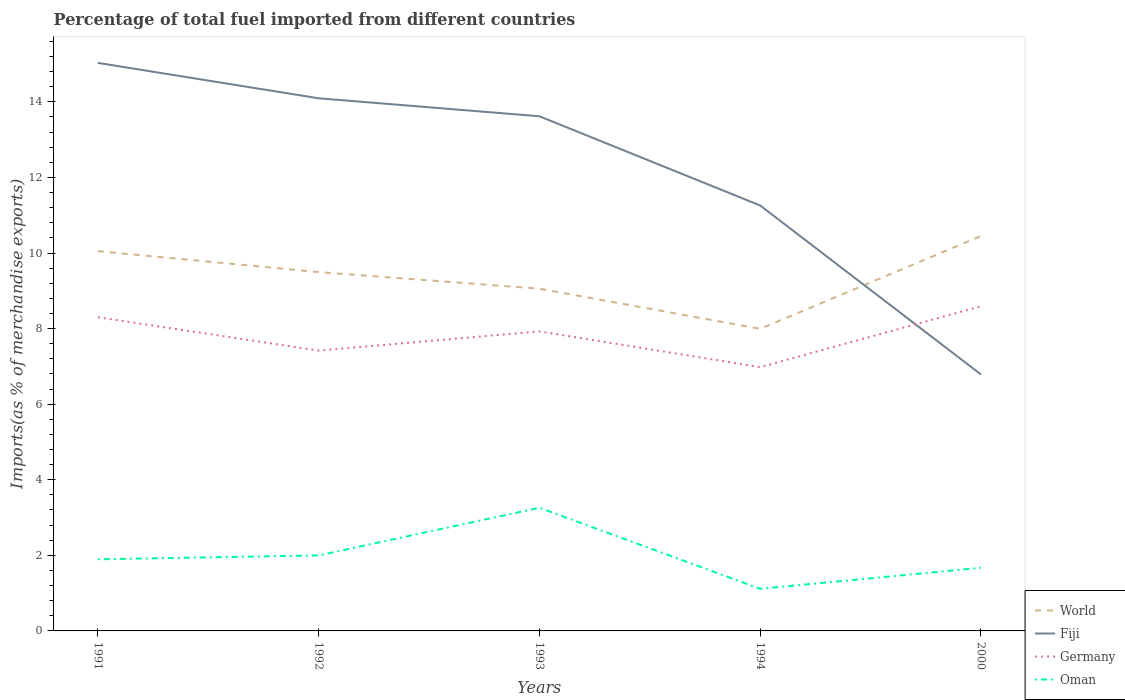Does the line corresponding to World intersect with the line corresponding to Oman?
Offer a terse response. No. Across all years, what is the maximum percentage of imports to different countries in World?
Provide a short and direct response. 7.99. In which year was the percentage of imports to different countries in Germany maximum?
Make the answer very short. 1994. What is the total percentage of imports to different countries in Germany in the graph?
Your answer should be very brief. -1.17. What is the difference between the highest and the second highest percentage of imports to different countries in World?
Your response must be concise. 2.45. What is the difference between the highest and the lowest percentage of imports to different countries in Fiji?
Make the answer very short. 3. How many lines are there?
Your answer should be very brief. 4. Does the graph contain any zero values?
Your response must be concise. No. Where does the legend appear in the graph?
Your response must be concise. Bottom right. What is the title of the graph?
Give a very brief answer. Percentage of total fuel imported from different countries. Does "Hong Kong" appear as one of the legend labels in the graph?
Your answer should be compact. No. What is the label or title of the X-axis?
Ensure brevity in your answer.  Years. What is the label or title of the Y-axis?
Offer a very short reply. Imports(as % of merchandise exports). What is the Imports(as % of merchandise exports) of World in 1991?
Your answer should be very brief. 10.05. What is the Imports(as % of merchandise exports) in Fiji in 1991?
Your response must be concise. 15.03. What is the Imports(as % of merchandise exports) of Germany in 1991?
Provide a succinct answer. 8.3. What is the Imports(as % of merchandise exports) of Oman in 1991?
Offer a terse response. 1.9. What is the Imports(as % of merchandise exports) of World in 1992?
Your answer should be compact. 9.5. What is the Imports(as % of merchandise exports) of Fiji in 1992?
Give a very brief answer. 14.09. What is the Imports(as % of merchandise exports) in Germany in 1992?
Make the answer very short. 7.42. What is the Imports(as % of merchandise exports) of Oman in 1992?
Offer a terse response. 2. What is the Imports(as % of merchandise exports) in World in 1993?
Your response must be concise. 9.06. What is the Imports(as % of merchandise exports) of Fiji in 1993?
Make the answer very short. 13.62. What is the Imports(as % of merchandise exports) in Germany in 1993?
Your answer should be very brief. 7.93. What is the Imports(as % of merchandise exports) in Oman in 1993?
Give a very brief answer. 3.26. What is the Imports(as % of merchandise exports) of World in 1994?
Provide a short and direct response. 7.99. What is the Imports(as % of merchandise exports) in Fiji in 1994?
Provide a short and direct response. 11.26. What is the Imports(as % of merchandise exports) of Germany in 1994?
Ensure brevity in your answer.  6.98. What is the Imports(as % of merchandise exports) in Oman in 1994?
Offer a terse response. 1.11. What is the Imports(as % of merchandise exports) of World in 2000?
Ensure brevity in your answer.  10.45. What is the Imports(as % of merchandise exports) in Fiji in 2000?
Keep it short and to the point. 6.79. What is the Imports(as % of merchandise exports) in Germany in 2000?
Your answer should be compact. 8.59. What is the Imports(as % of merchandise exports) in Oman in 2000?
Offer a very short reply. 1.67. Across all years, what is the maximum Imports(as % of merchandise exports) of World?
Offer a very short reply. 10.45. Across all years, what is the maximum Imports(as % of merchandise exports) of Fiji?
Make the answer very short. 15.03. Across all years, what is the maximum Imports(as % of merchandise exports) in Germany?
Your answer should be compact. 8.59. Across all years, what is the maximum Imports(as % of merchandise exports) in Oman?
Keep it short and to the point. 3.26. Across all years, what is the minimum Imports(as % of merchandise exports) of World?
Offer a terse response. 7.99. Across all years, what is the minimum Imports(as % of merchandise exports) in Fiji?
Your answer should be very brief. 6.79. Across all years, what is the minimum Imports(as % of merchandise exports) of Germany?
Give a very brief answer. 6.98. Across all years, what is the minimum Imports(as % of merchandise exports) in Oman?
Your answer should be compact. 1.11. What is the total Imports(as % of merchandise exports) in World in the graph?
Provide a succinct answer. 47.04. What is the total Imports(as % of merchandise exports) of Fiji in the graph?
Give a very brief answer. 60.79. What is the total Imports(as % of merchandise exports) of Germany in the graph?
Offer a terse response. 39.22. What is the total Imports(as % of merchandise exports) in Oman in the graph?
Offer a terse response. 9.94. What is the difference between the Imports(as % of merchandise exports) in World in 1991 and that in 1992?
Keep it short and to the point. 0.55. What is the difference between the Imports(as % of merchandise exports) of Fiji in 1991 and that in 1992?
Keep it short and to the point. 0.94. What is the difference between the Imports(as % of merchandise exports) of Germany in 1991 and that in 1992?
Your answer should be very brief. 0.88. What is the difference between the Imports(as % of merchandise exports) in Oman in 1991 and that in 1992?
Your response must be concise. -0.1. What is the difference between the Imports(as % of merchandise exports) of Fiji in 1991 and that in 1993?
Provide a succinct answer. 1.41. What is the difference between the Imports(as % of merchandise exports) of Germany in 1991 and that in 1993?
Your answer should be compact. 0.37. What is the difference between the Imports(as % of merchandise exports) in Oman in 1991 and that in 1993?
Make the answer very short. -1.36. What is the difference between the Imports(as % of merchandise exports) in World in 1991 and that in 1994?
Your answer should be very brief. 2.06. What is the difference between the Imports(as % of merchandise exports) of Fiji in 1991 and that in 1994?
Give a very brief answer. 3.77. What is the difference between the Imports(as % of merchandise exports) of Germany in 1991 and that in 1994?
Keep it short and to the point. 1.32. What is the difference between the Imports(as % of merchandise exports) of Oman in 1991 and that in 1994?
Ensure brevity in your answer.  0.78. What is the difference between the Imports(as % of merchandise exports) of World in 1991 and that in 2000?
Your response must be concise. -0.4. What is the difference between the Imports(as % of merchandise exports) of Fiji in 1991 and that in 2000?
Your response must be concise. 8.24. What is the difference between the Imports(as % of merchandise exports) of Germany in 1991 and that in 2000?
Give a very brief answer. -0.29. What is the difference between the Imports(as % of merchandise exports) in Oman in 1991 and that in 2000?
Give a very brief answer. 0.22. What is the difference between the Imports(as % of merchandise exports) of World in 1992 and that in 1993?
Provide a short and direct response. 0.44. What is the difference between the Imports(as % of merchandise exports) in Fiji in 1992 and that in 1993?
Make the answer very short. 0.48. What is the difference between the Imports(as % of merchandise exports) in Germany in 1992 and that in 1993?
Your response must be concise. -0.51. What is the difference between the Imports(as % of merchandise exports) in Oman in 1992 and that in 1993?
Make the answer very short. -1.26. What is the difference between the Imports(as % of merchandise exports) in World in 1992 and that in 1994?
Offer a terse response. 1.5. What is the difference between the Imports(as % of merchandise exports) in Fiji in 1992 and that in 1994?
Offer a terse response. 2.84. What is the difference between the Imports(as % of merchandise exports) in Germany in 1992 and that in 1994?
Give a very brief answer. 0.44. What is the difference between the Imports(as % of merchandise exports) in Oman in 1992 and that in 1994?
Your response must be concise. 0.88. What is the difference between the Imports(as % of merchandise exports) in World in 1992 and that in 2000?
Offer a very short reply. -0.95. What is the difference between the Imports(as % of merchandise exports) in Fiji in 1992 and that in 2000?
Your answer should be very brief. 7.31. What is the difference between the Imports(as % of merchandise exports) in Germany in 1992 and that in 2000?
Offer a very short reply. -1.17. What is the difference between the Imports(as % of merchandise exports) in Oman in 1992 and that in 2000?
Your answer should be compact. 0.33. What is the difference between the Imports(as % of merchandise exports) of World in 1993 and that in 1994?
Your response must be concise. 1.06. What is the difference between the Imports(as % of merchandise exports) in Fiji in 1993 and that in 1994?
Your response must be concise. 2.36. What is the difference between the Imports(as % of merchandise exports) in Germany in 1993 and that in 1994?
Make the answer very short. 0.95. What is the difference between the Imports(as % of merchandise exports) of Oman in 1993 and that in 1994?
Provide a succinct answer. 2.15. What is the difference between the Imports(as % of merchandise exports) of World in 1993 and that in 2000?
Your answer should be very brief. -1.39. What is the difference between the Imports(as % of merchandise exports) in Fiji in 1993 and that in 2000?
Provide a succinct answer. 6.83. What is the difference between the Imports(as % of merchandise exports) of Germany in 1993 and that in 2000?
Give a very brief answer. -0.66. What is the difference between the Imports(as % of merchandise exports) in Oman in 1993 and that in 2000?
Your answer should be compact. 1.59. What is the difference between the Imports(as % of merchandise exports) of World in 1994 and that in 2000?
Provide a short and direct response. -2.45. What is the difference between the Imports(as % of merchandise exports) in Fiji in 1994 and that in 2000?
Offer a terse response. 4.47. What is the difference between the Imports(as % of merchandise exports) in Germany in 1994 and that in 2000?
Ensure brevity in your answer.  -1.61. What is the difference between the Imports(as % of merchandise exports) in Oman in 1994 and that in 2000?
Offer a very short reply. -0.56. What is the difference between the Imports(as % of merchandise exports) in World in 1991 and the Imports(as % of merchandise exports) in Fiji in 1992?
Offer a very short reply. -4.05. What is the difference between the Imports(as % of merchandise exports) of World in 1991 and the Imports(as % of merchandise exports) of Germany in 1992?
Ensure brevity in your answer.  2.63. What is the difference between the Imports(as % of merchandise exports) of World in 1991 and the Imports(as % of merchandise exports) of Oman in 1992?
Your response must be concise. 8.05. What is the difference between the Imports(as % of merchandise exports) of Fiji in 1991 and the Imports(as % of merchandise exports) of Germany in 1992?
Make the answer very short. 7.61. What is the difference between the Imports(as % of merchandise exports) of Fiji in 1991 and the Imports(as % of merchandise exports) of Oman in 1992?
Make the answer very short. 13.03. What is the difference between the Imports(as % of merchandise exports) of Germany in 1991 and the Imports(as % of merchandise exports) of Oman in 1992?
Offer a terse response. 6.3. What is the difference between the Imports(as % of merchandise exports) in World in 1991 and the Imports(as % of merchandise exports) in Fiji in 1993?
Ensure brevity in your answer.  -3.57. What is the difference between the Imports(as % of merchandise exports) in World in 1991 and the Imports(as % of merchandise exports) in Germany in 1993?
Your response must be concise. 2.12. What is the difference between the Imports(as % of merchandise exports) of World in 1991 and the Imports(as % of merchandise exports) of Oman in 1993?
Make the answer very short. 6.79. What is the difference between the Imports(as % of merchandise exports) in Fiji in 1991 and the Imports(as % of merchandise exports) in Germany in 1993?
Make the answer very short. 7.11. What is the difference between the Imports(as % of merchandise exports) of Fiji in 1991 and the Imports(as % of merchandise exports) of Oman in 1993?
Offer a terse response. 11.77. What is the difference between the Imports(as % of merchandise exports) of Germany in 1991 and the Imports(as % of merchandise exports) of Oman in 1993?
Offer a very short reply. 5.04. What is the difference between the Imports(as % of merchandise exports) of World in 1991 and the Imports(as % of merchandise exports) of Fiji in 1994?
Provide a succinct answer. -1.21. What is the difference between the Imports(as % of merchandise exports) in World in 1991 and the Imports(as % of merchandise exports) in Germany in 1994?
Your answer should be very brief. 3.07. What is the difference between the Imports(as % of merchandise exports) in World in 1991 and the Imports(as % of merchandise exports) in Oman in 1994?
Make the answer very short. 8.94. What is the difference between the Imports(as % of merchandise exports) in Fiji in 1991 and the Imports(as % of merchandise exports) in Germany in 1994?
Ensure brevity in your answer.  8.05. What is the difference between the Imports(as % of merchandise exports) of Fiji in 1991 and the Imports(as % of merchandise exports) of Oman in 1994?
Your answer should be very brief. 13.92. What is the difference between the Imports(as % of merchandise exports) of Germany in 1991 and the Imports(as % of merchandise exports) of Oman in 1994?
Offer a very short reply. 7.19. What is the difference between the Imports(as % of merchandise exports) of World in 1991 and the Imports(as % of merchandise exports) of Fiji in 2000?
Offer a very short reply. 3.26. What is the difference between the Imports(as % of merchandise exports) of World in 1991 and the Imports(as % of merchandise exports) of Germany in 2000?
Offer a terse response. 1.46. What is the difference between the Imports(as % of merchandise exports) of World in 1991 and the Imports(as % of merchandise exports) of Oman in 2000?
Offer a terse response. 8.38. What is the difference between the Imports(as % of merchandise exports) in Fiji in 1991 and the Imports(as % of merchandise exports) in Germany in 2000?
Provide a succinct answer. 6.44. What is the difference between the Imports(as % of merchandise exports) in Fiji in 1991 and the Imports(as % of merchandise exports) in Oman in 2000?
Provide a short and direct response. 13.36. What is the difference between the Imports(as % of merchandise exports) in Germany in 1991 and the Imports(as % of merchandise exports) in Oman in 2000?
Offer a very short reply. 6.63. What is the difference between the Imports(as % of merchandise exports) of World in 1992 and the Imports(as % of merchandise exports) of Fiji in 1993?
Offer a very short reply. -4.12. What is the difference between the Imports(as % of merchandise exports) in World in 1992 and the Imports(as % of merchandise exports) in Germany in 1993?
Offer a very short reply. 1.57. What is the difference between the Imports(as % of merchandise exports) of World in 1992 and the Imports(as % of merchandise exports) of Oman in 1993?
Your answer should be compact. 6.24. What is the difference between the Imports(as % of merchandise exports) of Fiji in 1992 and the Imports(as % of merchandise exports) of Germany in 1993?
Your answer should be compact. 6.17. What is the difference between the Imports(as % of merchandise exports) in Fiji in 1992 and the Imports(as % of merchandise exports) in Oman in 1993?
Offer a very short reply. 10.84. What is the difference between the Imports(as % of merchandise exports) of Germany in 1992 and the Imports(as % of merchandise exports) of Oman in 1993?
Your response must be concise. 4.16. What is the difference between the Imports(as % of merchandise exports) in World in 1992 and the Imports(as % of merchandise exports) in Fiji in 1994?
Make the answer very short. -1.76. What is the difference between the Imports(as % of merchandise exports) of World in 1992 and the Imports(as % of merchandise exports) of Germany in 1994?
Provide a short and direct response. 2.52. What is the difference between the Imports(as % of merchandise exports) in World in 1992 and the Imports(as % of merchandise exports) in Oman in 1994?
Your response must be concise. 8.38. What is the difference between the Imports(as % of merchandise exports) of Fiji in 1992 and the Imports(as % of merchandise exports) of Germany in 1994?
Provide a short and direct response. 7.11. What is the difference between the Imports(as % of merchandise exports) of Fiji in 1992 and the Imports(as % of merchandise exports) of Oman in 1994?
Offer a very short reply. 12.98. What is the difference between the Imports(as % of merchandise exports) in Germany in 1992 and the Imports(as % of merchandise exports) in Oman in 1994?
Provide a short and direct response. 6.3. What is the difference between the Imports(as % of merchandise exports) of World in 1992 and the Imports(as % of merchandise exports) of Fiji in 2000?
Your answer should be very brief. 2.71. What is the difference between the Imports(as % of merchandise exports) of World in 1992 and the Imports(as % of merchandise exports) of Germany in 2000?
Offer a terse response. 0.91. What is the difference between the Imports(as % of merchandise exports) in World in 1992 and the Imports(as % of merchandise exports) in Oman in 2000?
Your response must be concise. 7.82. What is the difference between the Imports(as % of merchandise exports) of Fiji in 1992 and the Imports(as % of merchandise exports) of Germany in 2000?
Ensure brevity in your answer.  5.5. What is the difference between the Imports(as % of merchandise exports) in Fiji in 1992 and the Imports(as % of merchandise exports) in Oman in 2000?
Keep it short and to the point. 12.42. What is the difference between the Imports(as % of merchandise exports) in Germany in 1992 and the Imports(as % of merchandise exports) in Oman in 2000?
Provide a short and direct response. 5.75. What is the difference between the Imports(as % of merchandise exports) of World in 1993 and the Imports(as % of merchandise exports) of Fiji in 1994?
Make the answer very short. -2.2. What is the difference between the Imports(as % of merchandise exports) of World in 1993 and the Imports(as % of merchandise exports) of Germany in 1994?
Give a very brief answer. 2.08. What is the difference between the Imports(as % of merchandise exports) of World in 1993 and the Imports(as % of merchandise exports) of Oman in 1994?
Provide a short and direct response. 7.94. What is the difference between the Imports(as % of merchandise exports) of Fiji in 1993 and the Imports(as % of merchandise exports) of Germany in 1994?
Make the answer very short. 6.64. What is the difference between the Imports(as % of merchandise exports) of Fiji in 1993 and the Imports(as % of merchandise exports) of Oman in 1994?
Ensure brevity in your answer.  12.5. What is the difference between the Imports(as % of merchandise exports) in Germany in 1993 and the Imports(as % of merchandise exports) in Oman in 1994?
Give a very brief answer. 6.81. What is the difference between the Imports(as % of merchandise exports) of World in 1993 and the Imports(as % of merchandise exports) of Fiji in 2000?
Your response must be concise. 2.27. What is the difference between the Imports(as % of merchandise exports) in World in 1993 and the Imports(as % of merchandise exports) in Germany in 2000?
Offer a very short reply. 0.47. What is the difference between the Imports(as % of merchandise exports) in World in 1993 and the Imports(as % of merchandise exports) in Oman in 2000?
Give a very brief answer. 7.39. What is the difference between the Imports(as % of merchandise exports) of Fiji in 1993 and the Imports(as % of merchandise exports) of Germany in 2000?
Provide a short and direct response. 5.03. What is the difference between the Imports(as % of merchandise exports) in Fiji in 1993 and the Imports(as % of merchandise exports) in Oman in 2000?
Offer a terse response. 11.95. What is the difference between the Imports(as % of merchandise exports) of Germany in 1993 and the Imports(as % of merchandise exports) of Oman in 2000?
Make the answer very short. 6.26. What is the difference between the Imports(as % of merchandise exports) of World in 1994 and the Imports(as % of merchandise exports) of Fiji in 2000?
Keep it short and to the point. 1.21. What is the difference between the Imports(as % of merchandise exports) in World in 1994 and the Imports(as % of merchandise exports) in Germany in 2000?
Provide a succinct answer. -0.6. What is the difference between the Imports(as % of merchandise exports) in World in 1994 and the Imports(as % of merchandise exports) in Oman in 2000?
Your response must be concise. 6.32. What is the difference between the Imports(as % of merchandise exports) in Fiji in 1994 and the Imports(as % of merchandise exports) in Germany in 2000?
Offer a very short reply. 2.67. What is the difference between the Imports(as % of merchandise exports) of Fiji in 1994 and the Imports(as % of merchandise exports) of Oman in 2000?
Make the answer very short. 9.59. What is the difference between the Imports(as % of merchandise exports) in Germany in 1994 and the Imports(as % of merchandise exports) in Oman in 2000?
Ensure brevity in your answer.  5.31. What is the average Imports(as % of merchandise exports) in World per year?
Provide a succinct answer. 9.41. What is the average Imports(as % of merchandise exports) of Fiji per year?
Provide a short and direct response. 12.16. What is the average Imports(as % of merchandise exports) in Germany per year?
Provide a short and direct response. 7.84. What is the average Imports(as % of merchandise exports) in Oman per year?
Provide a short and direct response. 1.99. In the year 1991, what is the difference between the Imports(as % of merchandise exports) of World and Imports(as % of merchandise exports) of Fiji?
Provide a short and direct response. -4.98. In the year 1991, what is the difference between the Imports(as % of merchandise exports) in World and Imports(as % of merchandise exports) in Germany?
Make the answer very short. 1.75. In the year 1991, what is the difference between the Imports(as % of merchandise exports) in World and Imports(as % of merchandise exports) in Oman?
Your answer should be compact. 8.15. In the year 1991, what is the difference between the Imports(as % of merchandise exports) of Fiji and Imports(as % of merchandise exports) of Germany?
Give a very brief answer. 6.73. In the year 1991, what is the difference between the Imports(as % of merchandise exports) of Fiji and Imports(as % of merchandise exports) of Oman?
Make the answer very short. 13.14. In the year 1991, what is the difference between the Imports(as % of merchandise exports) in Germany and Imports(as % of merchandise exports) in Oman?
Give a very brief answer. 6.41. In the year 1992, what is the difference between the Imports(as % of merchandise exports) of World and Imports(as % of merchandise exports) of Fiji?
Give a very brief answer. -4.6. In the year 1992, what is the difference between the Imports(as % of merchandise exports) in World and Imports(as % of merchandise exports) in Germany?
Your answer should be very brief. 2.08. In the year 1992, what is the difference between the Imports(as % of merchandise exports) of World and Imports(as % of merchandise exports) of Oman?
Give a very brief answer. 7.5. In the year 1992, what is the difference between the Imports(as % of merchandise exports) in Fiji and Imports(as % of merchandise exports) in Germany?
Give a very brief answer. 6.68. In the year 1992, what is the difference between the Imports(as % of merchandise exports) in Fiji and Imports(as % of merchandise exports) in Oman?
Your response must be concise. 12.1. In the year 1992, what is the difference between the Imports(as % of merchandise exports) in Germany and Imports(as % of merchandise exports) in Oman?
Provide a short and direct response. 5.42. In the year 1993, what is the difference between the Imports(as % of merchandise exports) in World and Imports(as % of merchandise exports) in Fiji?
Ensure brevity in your answer.  -4.56. In the year 1993, what is the difference between the Imports(as % of merchandise exports) in World and Imports(as % of merchandise exports) in Germany?
Give a very brief answer. 1.13. In the year 1993, what is the difference between the Imports(as % of merchandise exports) in World and Imports(as % of merchandise exports) in Oman?
Your response must be concise. 5.8. In the year 1993, what is the difference between the Imports(as % of merchandise exports) in Fiji and Imports(as % of merchandise exports) in Germany?
Offer a very short reply. 5.69. In the year 1993, what is the difference between the Imports(as % of merchandise exports) of Fiji and Imports(as % of merchandise exports) of Oman?
Your answer should be compact. 10.36. In the year 1993, what is the difference between the Imports(as % of merchandise exports) in Germany and Imports(as % of merchandise exports) in Oman?
Ensure brevity in your answer.  4.67. In the year 1994, what is the difference between the Imports(as % of merchandise exports) of World and Imports(as % of merchandise exports) of Fiji?
Offer a very short reply. -3.26. In the year 1994, what is the difference between the Imports(as % of merchandise exports) in World and Imports(as % of merchandise exports) in Oman?
Your answer should be very brief. 6.88. In the year 1994, what is the difference between the Imports(as % of merchandise exports) in Fiji and Imports(as % of merchandise exports) in Germany?
Give a very brief answer. 4.28. In the year 1994, what is the difference between the Imports(as % of merchandise exports) of Fiji and Imports(as % of merchandise exports) of Oman?
Your answer should be compact. 10.14. In the year 1994, what is the difference between the Imports(as % of merchandise exports) of Germany and Imports(as % of merchandise exports) of Oman?
Provide a short and direct response. 5.87. In the year 2000, what is the difference between the Imports(as % of merchandise exports) in World and Imports(as % of merchandise exports) in Fiji?
Provide a short and direct response. 3.66. In the year 2000, what is the difference between the Imports(as % of merchandise exports) of World and Imports(as % of merchandise exports) of Germany?
Your answer should be compact. 1.86. In the year 2000, what is the difference between the Imports(as % of merchandise exports) of World and Imports(as % of merchandise exports) of Oman?
Your answer should be very brief. 8.78. In the year 2000, what is the difference between the Imports(as % of merchandise exports) in Fiji and Imports(as % of merchandise exports) in Germany?
Provide a short and direct response. -1.8. In the year 2000, what is the difference between the Imports(as % of merchandise exports) of Fiji and Imports(as % of merchandise exports) of Oman?
Ensure brevity in your answer.  5.12. In the year 2000, what is the difference between the Imports(as % of merchandise exports) of Germany and Imports(as % of merchandise exports) of Oman?
Keep it short and to the point. 6.92. What is the ratio of the Imports(as % of merchandise exports) of World in 1991 to that in 1992?
Provide a short and direct response. 1.06. What is the ratio of the Imports(as % of merchandise exports) in Fiji in 1991 to that in 1992?
Your answer should be compact. 1.07. What is the ratio of the Imports(as % of merchandise exports) in Germany in 1991 to that in 1992?
Keep it short and to the point. 1.12. What is the ratio of the Imports(as % of merchandise exports) in Oman in 1991 to that in 1992?
Offer a very short reply. 0.95. What is the ratio of the Imports(as % of merchandise exports) in World in 1991 to that in 1993?
Offer a very short reply. 1.11. What is the ratio of the Imports(as % of merchandise exports) of Fiji in 1991 to that in 1993?
Your answer should be very brief. 1.1. What is the ratio of the Imports(as % of merchandise exports) of Germany in 1991 to that in 1993?
Give a very brief answer. 1.05. What is the ratio of the Imports(as % of merchandise exports) of Oman in 1991 to that in 1993?
Your response must be concise. 0.58. What is the ratio of the Imports(as % of merchandise exports) in World in 1991 to that in 1994?
Ensure brevity in your answer.  1.26. What is the ratio of the Imports(as % of merchandise exports) of Fiji in 1991 to that in 1994?
Offer a very short reply. 1.34. What is the ratio of the Imports(as % of merchandise exports) of Germany in 1991 to that in 1994?
Keep it short and to the point. 1.19. What is the ratio of the Imports(as % of merchandise exports) in Oman in 1991 to that in 1994?
Provide a succinct answer. 1.7. What is the ratio of the Imports(as % of merchandise exports) of World in 1991 to that in 2000?
Give a very brief answer. 0.96. What is the ratio of the Imports(as % of merchandise exports) in Fiji in 1991 to that in 2000?
Your response must be concise. 2.21. What is the ratio of the Imports(as % of merchandise exports) in Germany in 1991 to that in 2000?
Offer a terse response. 0.97. What is the ratio of the Imports(as % of merchandise exports) in Oman in 1991 to that in 2000?
Your response must be concise. 1.13. What is the ratio of the Imports(as % of merchandise exports) in World in 1992 to that in 1993?
Your answer should be compact. 1.05. What is the ratio of the Imports(as % of merchandise exports) of Fiji in 1992 to that in 1993?
Your answer should be compact. 1.03. What is the ratio of the Imports(as % of merchandise exports) in Germany in 1992 to that in 1993?
Offer a very short reply. 0.94. What is the ratio of the Imports(as % of merchandise exports) of Oman in 1992 to that in 1993?
Your answer should be compact. 0.61. What is the ratio of the Imports(as % of merchandise exports) in World in 1992 to that in 1994?
Your response must be concise. 1.19. What is the ratio of the Imports(as % of merchandise exports) of Fiji in 1992 to that in 1994?
Keep it short and to the point. 1.25. What is the ratio of the Imports(as % of merchandise exports) of Germany in 1992 to that in 1994?
Keep it short and to the point. 1.06. What is the ratio of the Imports(as % of merchandise exports) in Oman in 1992 to that in 1994?
Your answer should be very brief. 1.79. What is the ratio of the Imports(as % of merchandise exports) of World in 1992 to that in 2000?
Provide a succinct answer. 0.91. What is the ratio of the Imports(as % of merchandise exports) of Fiji in 1992 to that in 2000?
Provide a succinct answer. 2.08. What is the ratio of the Imports(as % of merchandise exports) in Germany in 1992 to that in 2000?
Provide a short and direct response. 0.86. What is the ratio of the Imports(as % of merchandise exports) in Oman in 1992 to that in 2000?
Your response must be concise. 1.2. What is the ratio of the Imports(as % of merchandise exports) of World in 1993 to that in 1994?
Provide a succinct answer. 1.13. What is the ratio of the Imports(as % of merchandise exports) of Fiji in 1993 to that in 1994?
Keep it short and to the point. 1.21. What is the ratio of the Imports(as % of merchandise exports) of Germany in 1993 to that in 1994?
Offer a very short reply. 1.14. What is the ratio of the Imports(as % of merchandise exports) in Oman in 1993 to that in 1994?
Keep it short and to the point. 2.93. What is the ratio of the Imports(as % of merchandise exports) of World in 1993 to that in 2000?
Offer a terse response. 0.87. What is the ratio of the Imports(as % of merchandise exports) in Fiji in 1993 to that in 2000?
Make the answer very short. 2.01. What is the ratio of the Imports(as % of merchandise exports) in Germany in 1993 to that in 2000?
Give a very brief answer. 0.92. What is the ratio of the Imports(as % of merchandise exports) in Oman in 1993 to that in 2000?
Your response must be concise. 1.95. What is the ratio of the Imports(as % of merchandise exports) in World in 1994 to that in 2000?
Offer a very short reply. 0.77. What is the ratio of the Imports(as % of merchandise exports) of Fiji in 1994 to that in 2000?
Offer a very short reply. 1.66. What is the ratio of the Imports(as % of merchandise exports) in Germany in 1994 to that in 2000?
Provide a succinct answer. 0.81. What is the ratio of the Imports(as % of merchandise exports) in Oman in 1994 to that in 2000?
Offer a terse response. 0.67. What is the difference between the highest and the second highest Imports(as % of merchandise exports) in World?
Make the answer very short. 0.4. What is the difference between the highest and the second highest Imports(as % of merchandise exports) of Fiji?
Keep it short and to the point. 0.94. What is the difference between the highest and the second highest Imports(as % of merchandise exports) of Germany?
Ensure brevity in your answer.  0.29. What is the difference between the highest and the second highest Imports(as % of merchandise exports) in Oman?
Ensure brevity in your answer.  1.26. What is the difference between the highest and the lowest Imports(as % of merchandise exports) in World?
Your response must be concise. 2.45. What is the difference between the highest and the lowest Imports(as % of merchandise exports) in Fiji?
Your response must be concise. 8.24. What is the difference between the highest and the lowest Imports(as % of merchandise exports) of Germany?
Your response must be concise. 1.61. What is the difference between the highest and the lowest Imports(as % of merchandise exports) of Oman?
Give a very brief answer. 2.15. 